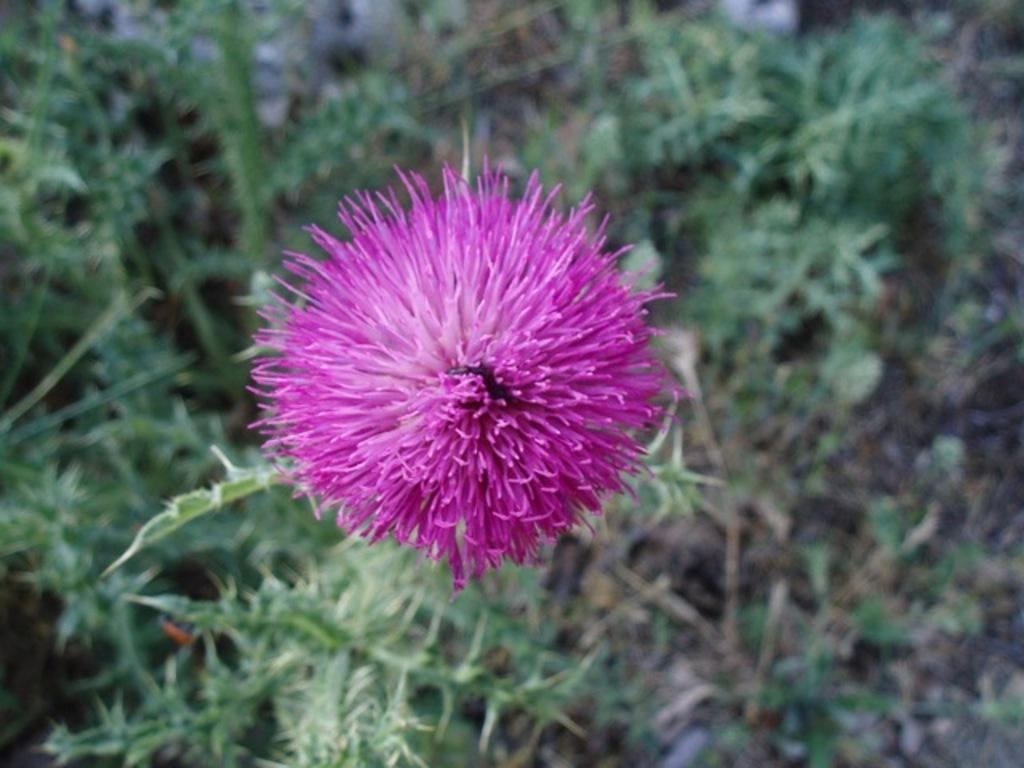What is the main subject of the image? There is a beautiful flower in the image. Can you describe the background of the image? The background of the image is blurred. How many balls are being held by the arm in the image? There is no arm or balls present in the image; it features a beautiful flower with a blurred background. 